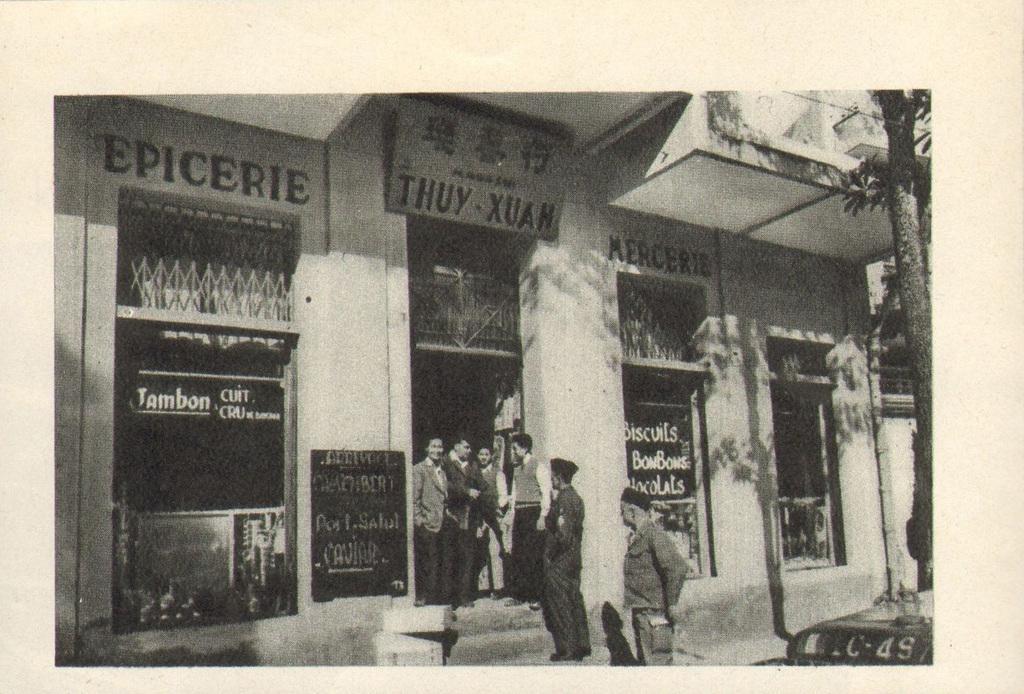Please provide a concise description of this image. It is a black and white picture. In this picture I can see people, tree, boards, grilles and walls. Something is written on these boards. 